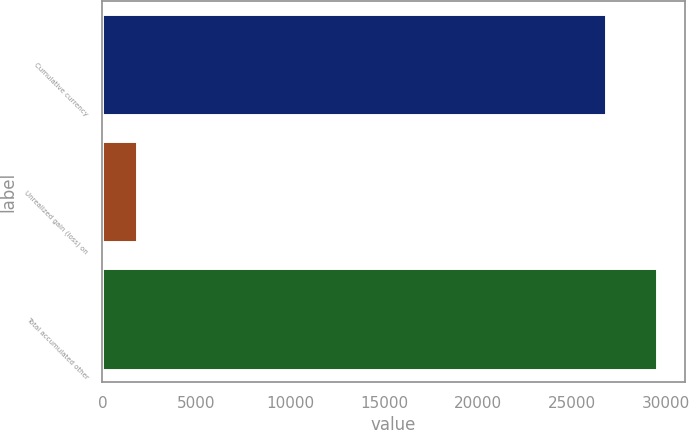Convert chart. <chart><loc_0><loc_0><loc_500><loc_500><bar_chart><fcel>Cumulative currency<fcel>Unrealized gain (loss) on<fcel>Total accumulated other<nl><fcel>26848<fcel>1847<fcel>29532.8<nl></chart> 